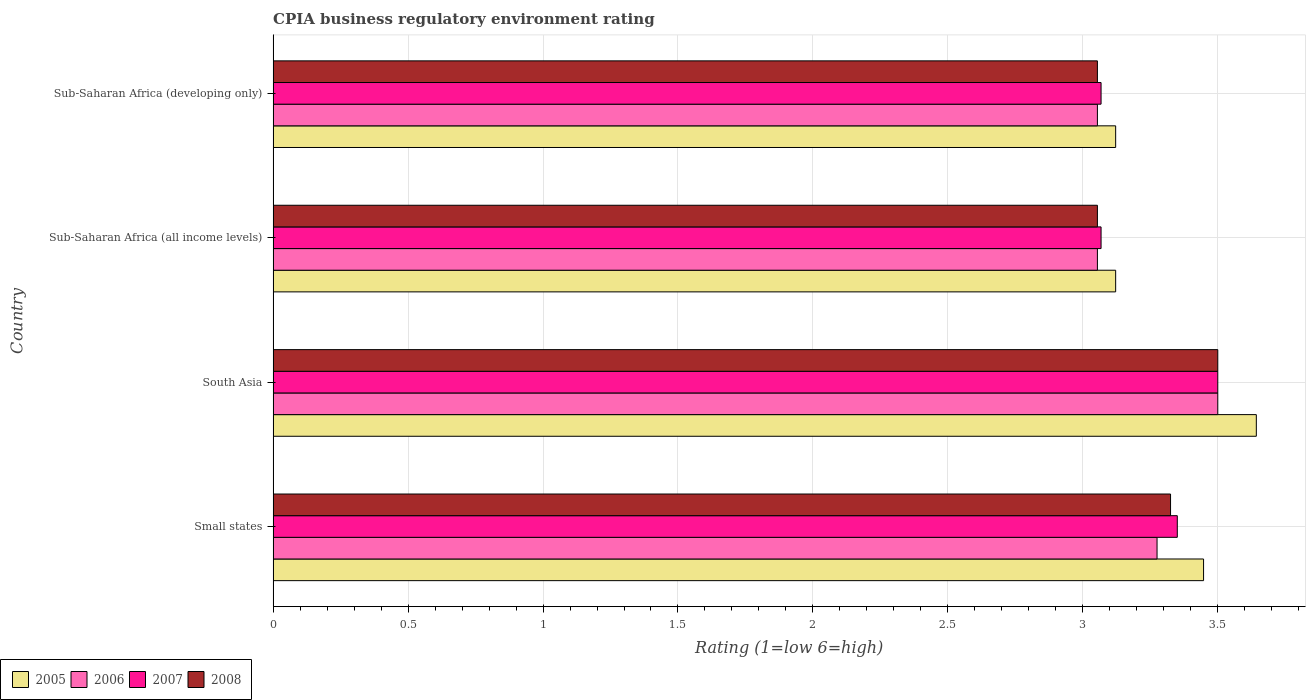Are the number of bars per tick equal to the number of legend labels?
Ensure brevity in your answer.  Yes. Are the number of bars on each tick of the Y-axis equal?
Give a very brief answer. Yes. How many bars are there on the 1st tick from the top?
Your response must be concise. 4. How many bars are there on the 1st tick from the bottom?
Offer a very short reply. 4. What is the label of the 2nd group of bars from the top?
Your answer should be compact. Sub-Saharan Africa (all income levels). In how many cases, is the number of bars for a given country not equal to the number of legend labels?
Offer a very short reply. 0. What is the CPIA rating in 2006 in Sub-Saharan Africa (developing only)?
Offer a terse response. 3.05. Across all countries, what is the minimum CPIA rating in 2008?
Your response must be concise. 3.05. In which country was the CPIA rating in 2006 minimum?
Offer a very short reply. Sub-Saharan Africa (all income levels). What is the total CPIA rating in 2007 in the graph?
Offer a terse response. 12.99. What is the difference between the CPIA rating in 2005 in Small states and that in Sub-Saharan Africa (developing only)?
Provide a succinct answer. 0.33. What is the difference between the CPIA rating in 2006 in Sub-Saharan Africa (all income levels) and the CPIA rating in 2008 in Small states?
Offer a very short reply. -0.27. What is the average CPIA rating in 2005 per country?
Provide a succinct answer. 3.33. What is the difference between the CPIA rating in 2005 and CPIA rating in 2008 in South Asia?
Your response must be concise. 0.14. In how many countries, is the CPIA rating in 2007 greater than 0.1 ?
Ensure brevity in your answer.  4. What is the ratio of the CPIA rating in 2007 in Small states to that in Sub-Saharan Africa (all income levels)?
Offer a very short reply. 1.09. What is the difference between the highest and the second highest CPIA rating in 2005?
Offer a very short reply. 0.2. What is the difference between the highest and the lowest CPIA rating in 2008?
Keep it short and to the point. 0.45. Is it the case that in every country, the sum of the CPIA rating in 2005 and CPIA rating in 2006 is greater than the sum of CPIA rating in 2007 and CPIA rating in 2008?
Give a very brief answer. No. How many countries are there in the graph?
Keep it short and to the point. 4. Where does the legend appear in the graph?
Keep it short and to the point. Bottom left. How many legend labels are there?
Your answer should be very brief. 4. How are the legend labels stacked?
Provide a short and direct response. Horizontal. What is the title of the graph?
Your answer should be very brief. CPIA business regulatory environment rating. Does "1993" appear as one of the legend labels in the graph?
Give a very brief answer. No. What is the label or title of the X-axis?
Make the answer very short. Rating (1=low 6=high). What is the Rating (1=low 6=high) of 2005 in Small states?
Your response must be concise. 3.45. What is the Rating (1=low 6=high) of 2006 in Small states?
Offer a terse response. 3.27. What is the Rating (1=low 6=high) in 2007 in Small states?
Your response must be concise. 3.35. What is the Rating (1=low 6=high) in 2008 in Small states?
Offer a very short reply. 3.33. What is the Rating (1=low 6=high) in 2005 in South Asia?
Provide a succinct answer. 3.64. What is the Rating (1=low 6=high) in 2007 in South Asia?
Your answer should be very brief. 3.5. What is the Rating (1=low 6=high) in 2008 in South Asia?
Ensure brevity in your answer.  3.5. What is the Rating (1=low 6=high) in 2005 in Sub-Saharan Africa (all income levels)?
Your response must be concise. 3.12. What is the Rating (1=low 6=high) in 2006 in Sub-Saharan Africa (all income levels)?
Ensure brevity in your answer.  3.05. What is the Rating (1=low 6=high) in 2007 in Sub-Saharan Africa (all income levels)?
Make the answer very short. 3.07. What is the Rating (1=low 6=high) in 2008 in Sub-Saharan Africa (all income levels)?
Provide a short and direct response. 3.05. What is the Rating (1=low 6=high) of 2005 in Sub-Saharan Africa (developing only)?
Keep it short and to the point. 3.12. What is the Rating (1=low 6=high) of 2006 in Sub-Saharan Africa (developing only)?
Keep it short and to the point. 3.05. What is the Rating (1=low 6=high) of 2007 in Sub-Saharan Africa (developing only)?
Your answer should be very brief. 3.07. What is the Rating (1=low 6=high) of 2008 in Sub-Saharan Africa (developing only)?
Your answer should be very brief. 3.05. Across all countries, what is the maximum Rating (1=low 6=high) in 2005?
Your answer should be very brief. 3.64. Across all countries, what is the maximum Rating (1=low 6=high) in 2006?
Ensure brevity in your answer.  3.5. Across all countries, what is the maximum Rating (1=low 6=high) in 2008?
Give a very brief answer. 3.5. Across all countries, what is the minimum Rating (1=low 6=high) of 2005?
Offer a terse response. 3.12. Across all countries, what is the minimum Rating (1=low 6=high) in 2006?
Your answer should be compact. 3.05. Across all countries, what is the minimum Rating (1=low 6=high) in 2007?
Your answer should be very brief. 3.07. Across all countries, what is the minimum Rating (1=low 6=high) in 2008?
Make the answer very short. 3.05. What is the total Rating (1=low 6=high) of 2005 in the graph?
Provide a succinct answer. 13.33. What is the total Rating (1=low 6=high) of 2006 in the graph?
Make the answer very short. 12.88. What is the total Rating (1=low 6=high) in 2007 in the graph?
Your response must be concise. 12.99. What is the total Rating (1=low 6=high) of 2008 in the graph?
Provide a succinct answer. 12.93. What is the difference between the Rating (1=low 6=high) of 2005 in Small states and that in South Asia?
Give a very brief answer. -0.2. What is the difference between the Rating (1=low 6=high) in 2006 in Small states and that in South Asia?
Your answer should be compact. -0.23. What is the difference between the Rating (1=low 6=high) in 2008 in Small states and that in South Asia?
Provide a short and direct response. -0.17. What is the difference between the Rating (1=low 6=high) of 2005 in Small states and that in Sub-Saharan Africa (all income levels)?
Offer a very short reply. 0.33. What is the difference between the Rating (1=low 6=high) of 2006 in Small states and that in Sub-Saharan Africa (all income levels)?
Give a very brief answer. 0.22. What is the difference between the Rating (1=low 6=high) in 2007 in Small states and that in Sub-Saharan Africa (all income levels)?
Keep it short and to the point. 0.28. What is the difference between the Rating (1=low 6=high) in 2008 in Small states and that in Sub-Saharan Africa (all income levels)?
Offer a very short reply. 0.27. What is the difference between the Rating (1=low 6=high) of 2005 in Small states and that in Sub-Saharan Africa (developing only)?
Keep it short and to the point. 0.33. What is the difference between the Rating (1=low 6=high) of 2006 in Small states and that in Sub-Saharan Africa (developing only)?
Give a very brief answer. 0.22. What is the difference between the Rating (1=low 6=high) in 2007 in Small states and that in Sub-Saharan Africa (developing only)?
Your answer should be very brief. 0.28. What is the difference between the Rating (1=low 6=high) of 2008 in Small states and that in Sub-Saharan Africa (developing only)?
Offer a terse response. 0.27. What is the difference between the Rating (1=low 6=high) in 2005 in South Asia and that in Sub-Saharan Africa (all income levels)?
Make the answer very short. 0.52. What is the difference between the Rating (1=low 6=high) of 2006 in South Asia and that in Sub-Saharan Africa (all income levels)?
Ensure brevity in your answer.  0.45. What is the difference between the Rating (1=low 6=high) in 2007 in South Asia and that in Sub-Saharan Africa (all income levels)?
Make the answer very short. 0.43. What is the difference between the Rating (1=low 6=high) of 2008 in South Asia and that in Sub-Saharan Africa (all income levels)?
Your response must be concise. 0.45. What is the difference between the Rating (1=low 6=high) of 2005 in South Asia and that in Sub-Saharan Africa (developing only)?
Your answer should be very brief. 0.52. What is the difference between the Rating (1=low 6=high) in 2006 in South Asia and that in Sub-Saharan Africa (developing only)?
Provide a short and direct response. 0.45. What is the difference between the Rating (1=low 6=high) of 2007 in South Asia and that in Sub-Saharan Africa (developing only)?
Your answer should be compact. 0.43. What is the difference between the Rating (1=low 6=high) of 2008 in South Asia and that in Sub-Saharan Africa (developing only)?
Offer a very short reply. 0.45. What is the difference between the Rating (1=low 6=high) of 2006 in Sub-Saharan Africa (all income levels) and that in Sub-Saharan Africa (developing only)?
Offer a terse response. 0. What is the difference between the Rating (1=low 6=high) of 2007 in Sub-Saharan Africa (all income levels) and that in Sub-Saharan Africa (developing only)?
Offer a very short reply. 0. What is the difference between the Rating (1=low 6=high) in 2008 in Sub-Saharan Africa (all income levels) and that in Sub-Saharan Africa (developing only)?
Offer a very short reply. 0. What is the difference between the Rating (1=low 6=high) of 2005 in Small states and the Rating (1=low 6=high) of 2006 in South Asia?
Offer a very short reply. -0.05. What is the difference between the Rating (1=low 6=high) in 2005 in Small states and the Rating (1=low 6=high) in 2007 in South Asia?
Your answer should be very brief. -0.05. What is the difference between the Rating (1=low 6=high) in 2005 in Small states and the Rating (1=low 6=high) in 2008 in South Asia?
Offer a terse response. -0.05. What is the difference between the Rating (1=low 6=high) in 2006 in Small states and the Rating (1=low 6=high) in 2007 in South Asia?
Offer a terse response. -0.23. What is the difference between the Rating (1=low 6=high) in 2006 in Small states and the Rating (1=low 6=high) in 2008 in South Asia?
Your response must be concise. -0.23. What is the difference between the Rating (1=low 6=high) of 2007 in Small states and the Rating (1=low 6=high) of 2008 in South Asia?
Provide a short and direct response. -0.15. What is the difference between the Rating (1=low 6=high) of 2005 in Small states and the Rating (1=low 6=high) of 2006 in Sub-Saharan Africa (all income levels)?
Your response must be concise. 0.39. What is the difference between the Rating (1=low 6=high) of 2005 in Small states and the Rating (1=low 6=high) of 2007 in Sub-Saharan Africa (all income levels)?
Provide a short and direct response. 0.38. What is the difference between the Rating (1=low 6=high) in 2005 in Small states and the Rating (1=low 6=high) in 2008 in Sub-Saharan Africa (all income levels)?
Offer a terse response. 0.39. What is the difference between the Rating (1=low 6=high) in 2006 in Small states and the Rating (1=low 6=high) in 2007 in Sub-Saharan Africa (all income levels)?
Offer a terse response. 0.21. What is the difference between the Rating (1=low 6=high) in 2006 in Small states and the Rating (1=low 6=high) in 2008 in Sub-Saharan Africa (all income levels)?
Give a very brief answer. 0.22. What is the difference between the Rating (1=low 6=high) of 2007 in Small states and the Rating (1=low 6=high) of 2008 in Sub-Saharan Africa (all income levels)?
Ensure brevity in your answer.  0.3. What is the difference between the Rating (1=low 6=high) of 2005 in Small states and the Rating (1=low 6=high) of 2006 in Sub-Saharan Africa (developing only)?
Your answer should be very brief. 0.39. What is the difference between the Rating (1=low 6=high) in 2005 in Small states and the Rating (1=low 6=high) in 2007 in Sub-Saharan Africa (developing only)?
Provide a short and direct response. 0.38. What is the difference between the Rating (1=low 6=high) in 2005 in Small states and the Rating (1=low 6=high) in 2008 in Sub-Saharan Africa (developing only)?
Ensure brevity in your answer.  0.39. What is the difference between the Rating (1=low 6=high) in 2006 in Small states and the Rating (1=low 6=high) in 2007 in Sub-Saharan Africa (developing only)?
Your response must be concise. 0.21. What is the difference between the Rating (1=low 6=high) of 2006 in Small states and the Rating (1=low 6=high) of 2008 in Sub-Saharan Africa (developing only)?
Your response must be concise. 0.22. What is the difference between the Rating (1=low 6=high) in 2007 in Small states and the Rating (1=low 6=high) in 2008 in Sub-Saharan Africa (developing only)?
Give a very brief answer. 0.3. What is the difference between the Rating (1=low 6=high) of 2005 in South Asia and the Rating (1=low 6=high) of 2006 in Sub-Saharan Africa (all income levels)?
Your answer should be very brief. 0.59. What is the difference between the Rating (1=low 6=high) of 2005 in South Asia and the Rating (1=low 6=high) of 2007 in Sub-Saharan Africa (all income levels)?
Ensure brevity in your answer.  0.58. What is the difference between the Rating (1=low 6=high) of 2005 in South Asia and the Rating (1=low 6=high) of 2008 in Sub-Saharan Africa (all income levels)?
Provide a short and direct response. 0.59. What is the difference between the Rating (1=low 6=high) of 2006 in South Asia and the Rating (1=low 6=high) of 2007 in Sub-Saharan Africa (all income levels)?
Provide a short and direct response. 0.43. What is the difference between the Rating (1=low 6=high) of 2006 in South Asia and the Rating (1=low 6=high) of 2008 in Sub-Saharan Africa (all income levels)?
Offer a terse response. 0.45. What is the difference between the Rating (1=low 6=high) of 2007 in South Asia and the Rating (1=low 6=high) of 2008 in Sub-Saharan Africa (all income levels)?
Your response must be concise. 0.45. What is the difference between the Rating (1=low 6=high) of 2005 in South Asia and the Rating (1=low 6=high) of 2006 in Sub-Saharan Africa (developing only)?
Ensure brevity in your answer.  0.59. What is the difference between the Rating (1=low 6=high) in 2005 in South Asia and the Rating (1=low 6=high) in 2007 in Sub-Saharan Africa (developing only)?
Provide a short and direct response. 0.58. What is the difference between the Rating (1=low 6=high) of 2005 in South Asia and the Rating (1=low 6=high) of 2008 in Sub-Saharan Africa (developing only)?
Provide a succinct answer. 0.59. What is the difference between the Rating (1=low 6=high) in 2006 in South Asia and the Rating (1=low 6=high) in 2007 in Sub-Saharan Africa (developing only)?
Make the answer very short. 0.43. What is the difference between the Rating (1=low 6=high) of 2006 in South Asia and the Rating (1=low 6=high) of 2008 in Sub-Saharan Africa (developing only)?
Your answer should be very brief. 0.45. What is the difference between the Rating (1=low 6=high) of 2007 in South Asia and the Rating (1=low 6=high) of 2008 in Sub-Saharan Africa (developing only)?
Offer a terse response. 0.45. What is the difference between the Rating (1=low 6=high) in 2005 in Sub-Saharan Africa (all income levels) and the Rating (1=low 6=high) in 2006 in Sub-Saharan Africa (developing only)?
Your response must be concise. 0.07. What is the difference between the Rating (1=low 6=high) in 2005 in Sub-Saharan Africa (all income levels) and the Rating (1=low 6=high) in 2007 in Sub-Saharan Africa (developing only)?
Your response must be concise. 0.05. What is the difference between the Rating (1=low 6=high) in 2005 in Sub-Saharan Africa (all income levels) and the Rating (1=low 6=high) in 2008 in Sub-Saharan Africa (developing only)?
Provide a short and direct response. 0.07. What is the difference between the Rating (1=low 6=high) of 2006 in Sub-Saharan Africa (all income levels) and the Rating (1=low 6=high) of 2007 in Sub-Saharan Africa (developing only)?
Provide a succinct answer. -0.01. What is the difference between the Rating (1=low 6=high) of 2007 in Sub-Saharan Africa (all income levels) and the Rating (1=low 6=high) of 2008 in Sub-Saharan Africa (developing only)?
Your answer should be very brief. 0.01. What is the average Rating (1=low 6=high) in 2005 per country?
Make the answer very short. 3.33. What is the average Rating (1=low 6=high) in 2006 per country?
Your answer should be compact. 3.22. What is the average Rating (1=low 6=high) in 2007 per country?
Ensure brevity in your answer.  3.25. What is the average Rating (1=low 6=high) in 2008 per country?
Provide a succinct answer. 3.23. What is the difference between the Rating (1=low 6=high) in 2005 and Rating (1=low 6=high) in 2006 in Small states?
Provide a short and direct response. 0.17. What is the difference between the Rating (1=low 6=high) of 2005 and Rating (1=low 6=high) of 2007 in Small states?
Provide a short and direct response. 0.1. What is the difference between the Rating (1=low 6=high) of 2005 and Rating (1=low 6=high) of 2008 in Small states?
Offer a terse response. 0.12. What is the difference between the Rating (1=low 6=high) of 2006 and Rating (1=low 6=high) of 2007 in Small states?
Make the answer very short. -0.07. What is the difference between the Rating (1=low 6=high) in 2006 and Rating (1=low 6=high) in 2008 in Small states?
Your answer should be very brief. -0.05. What is the difference between the Rating (1=low 6=high) of 2007 and Rating (1=low 6=high) of 2008 in Small states?
Give a very brief answer. 0.03. What is the difference between the Rating (1=low 6=high) of 2005 and Rating (1=low 6=high) of 2006 in South Asia?
Your response must be concise. 0.14. What is the difference between the Rating (1=low 6=high) of 2005 and Rating (1=low 6=high) of 2007 in South Asia?
Ensure brevity in your answer.  0.14. What is the difference between the Rating (1=low 6=high) of 2005 and Rating (1=low 6=high) of 2008 in South Asia?
Make the answer very short. 0.14. What is the difference between the Rating (1=low 6=high) in 2006 and Rating (1=low 6=high) in 2008 in South Asia?
Keep it short and to the point. 0. What is the difference between the Rating (1=low 6=high) in 2005 and Rating (1=low 6=high) in 2006 in Sub-Saharan Africa (all income levels)?
Offer a terse response. 0.07. What is the difference between the Rating (1=low 6=high) in 2005 and Rating (1=low 6=high) in 2007 in Sub-Saharan Africa (all income levels)?
Your answer should be compact. 0.05. What is the difference between the Rating (1=low 6=high) of 2005 and Rating (1=low 6=high) of 2008 in Sub-Saharan Africa (all income levels)?
Provide a succinct answer. 0.07. What is the difference between the Rating (1=low 6=high) in 2006 and Rating (1=low 6=high) in 2007 in Sub-Saharan Africa (all income levels)?
Provide a short and direct response. -0.01. What is the difference between the Rating (1=low 6=high) of 2006 and Rating (1=low 6=high) of 2008 in Sub-Saharan Africa (all income levels)?
Keep it short and to the point. 0. What is the difference between the Rating (1=low 6=high) of 2007 and Rating (1=low 6=high) of 2008 in Sub-Saharan Africa (all income levels)?
Your response must be concise. 0.01. What is the difference between the Rating (1=low 6=high) in 2005 and Rating (1=low 6=high) in 2006 in Sub-Saharan Africa (developing only)?
Your answer should be very brief. 0.07. What is the difference between the Rating (1=low 6=high) in 2005 and Rating (1=low 6=high) in 2007 in Sub-Saharan Africa (developing only)?
Provide a succinct answer. 0.05. What is the difference between the Rating (1=low 6=high) of 2005 and Rating (1=low 6=high) of 2008 in Sub-Saharan Africa (developing only)?
Make the answer very short. 0.07. What is the difference between the Rating (1=low 6=high) of 2006 and Rating (1=low 6=high) of 2007 in Sub-Saharan Africa (developing only)?
Give a very brief answer. -0.01. What is the difference between the Rating (1=low 6=high) in 2007 and Rating (1=low 6=high) in 2008 in Sub-Saharan Africa (developing only)?
Ensure brevity in your answer.  0.01. What is the ratio of the Rating (1=low 6=high) in 2005 in Small states to that in South Asia?
Offer a terse response. 0.95. What is the ratio of the Rating (1=low 6=high) of 2006 in Small states to that in South Asia?
Your response must be concise. 0.94. What is the ratio of the Rating (1=low 6=high) of 2007 in Small states to that in South Asia?
Provide a succinct answer. 0.96. What is the ratio of the Rating (1=low 6=high) of 2008 in Small states to that in South Asia?
Your response must be concise. 0.95. What is the ratio of the Rating (1=low 6=high) of 2005 in Small states to that in Sub-Saharan Africa (all income levels)?
Your answer should be very brief. 1.1. What is the ratio of the Rating (1=low 6=high) of 2006 in Small states to that in Sub-Saharan Africa (all income levels)?
Your answer should be very brief. 1.07. What is the ratio of the Rating (1=low 6=high) in 2007 in Small states to that in Sub-Saharan Africa (all income levels)?
Ensure brevity in your answer.  1.09. What is the ratio of the Rating (1=low 6=high) of 2008 in Small states to that in Sub-Saharan Africa (all income levels)?
Make the answer very short. 1.09. What is the ratio of the Rating (1=low 6=high) of 2005 in Small states to that in Sub-Saharan Africa (developing only)?
Your answer should be very brief. 1.1. What is the ratio of the Rating (1=low 6=high) of 2006 in Small states to that in Sub-Saharan Africa (developing only)?
Ensure brevity in your answer.  1.07. What is the ratio of the Rating (1=low 6=high) of 2007 in Small states to that in Sub-Saharan Africa (developing only)?
Keep it short and to the point. 1.09. What is the ratio of the Rating (1=low 6=high) in 2008 in Small states to that in Sub-Saharan Africa (developing only)?
Provide a succinct answer. 1.09. What is the ratio of the Rating (1=low 6=high) in 2005 in South Asia to that in Sub-Saharan Africa (all income levels)?
Ensure brevity in your answer.  1.17. What is the ratio of the Rating (1=low 6=high) in 2006 in South Asia to that in Sub-Saharan Africa (all income levels)?
Keep it short and to the point. 1.15. What is the ratio of the Rating (1=low 6=high) in 2007 in South Asia to that in Sub-Saharan Africa (all income levels)?
Your answer should be very brief. 1.14. What is the ratio of the Rating (1=low 6=high) in 2008 in South Asia to that in Sub-Saharan Africa (all income levels)?
Offer a very short reply. 1.15. What is the ratio of the Rating (1=low 6=high) in 2005 in South Asia to that in Sub-Saharan Africa (developing only)?
Give a very brief answer. 1.17. What is the ratio of the Rating (1=low 6=high) in 2006 in South Asia to that in Sub-Saharan Africa (developing only)?
Make the answer very short. 1.15. What is the ratio of the Rating (1=low 6=high) of 2007 in South Asia to that in Sub-Saharan Africa (developing only)?
Keep it short and to the point. 1.14. What is the ratio of the Rating (1=low 6=high) of 2008 in South Asia to that in Sub-Saharan Africa (developing only)?
Make the answer very short. 1.15. What is the ratio of the Rating (1=low 6=high) of 2005 in Sub-Saharan Africa (all income levels) to that in Sub-Saharan Africa (developing only)?
Ensure brevity in your answer.  1. What is the ratio of the Rating (1=low 6=high) of 2007 in Sub-Saharan Africa (all income levels) to that in Sub-Saharan Africa (developing only)?
Ensure brevity in your answer.  1. What is the difference between the highest and the second highest Rating (1=low 6=high) in 2005?
Ensure brevity in your answer.  0.2. What is the difference between the highest and the second highest Rating (1=low 6=high) of 2006?
Provide a succinct answer. 0.23. What is the difference between the highest and the second highest Rating (1=low 6=high) in 2008?
Ensure brevity in your answer.  0.17. What is the difference between the highest and the lowest Rating (1=low 6=high) of 2005?
Your answer should be very brief. 0.52. What is the difference between the highest and the lowest Rating (1=low 6=high) of 2006?
Make the answer very short. 0.45. What is the difference between the highest and the lowest Rating (1=low 6=high) in 2007?
Provide a short and direct response. 0.43. What is the difference between the highest and the lowest Rating (1=low 6=high) of 2008?
Provide a short and direct response. 0.45. 